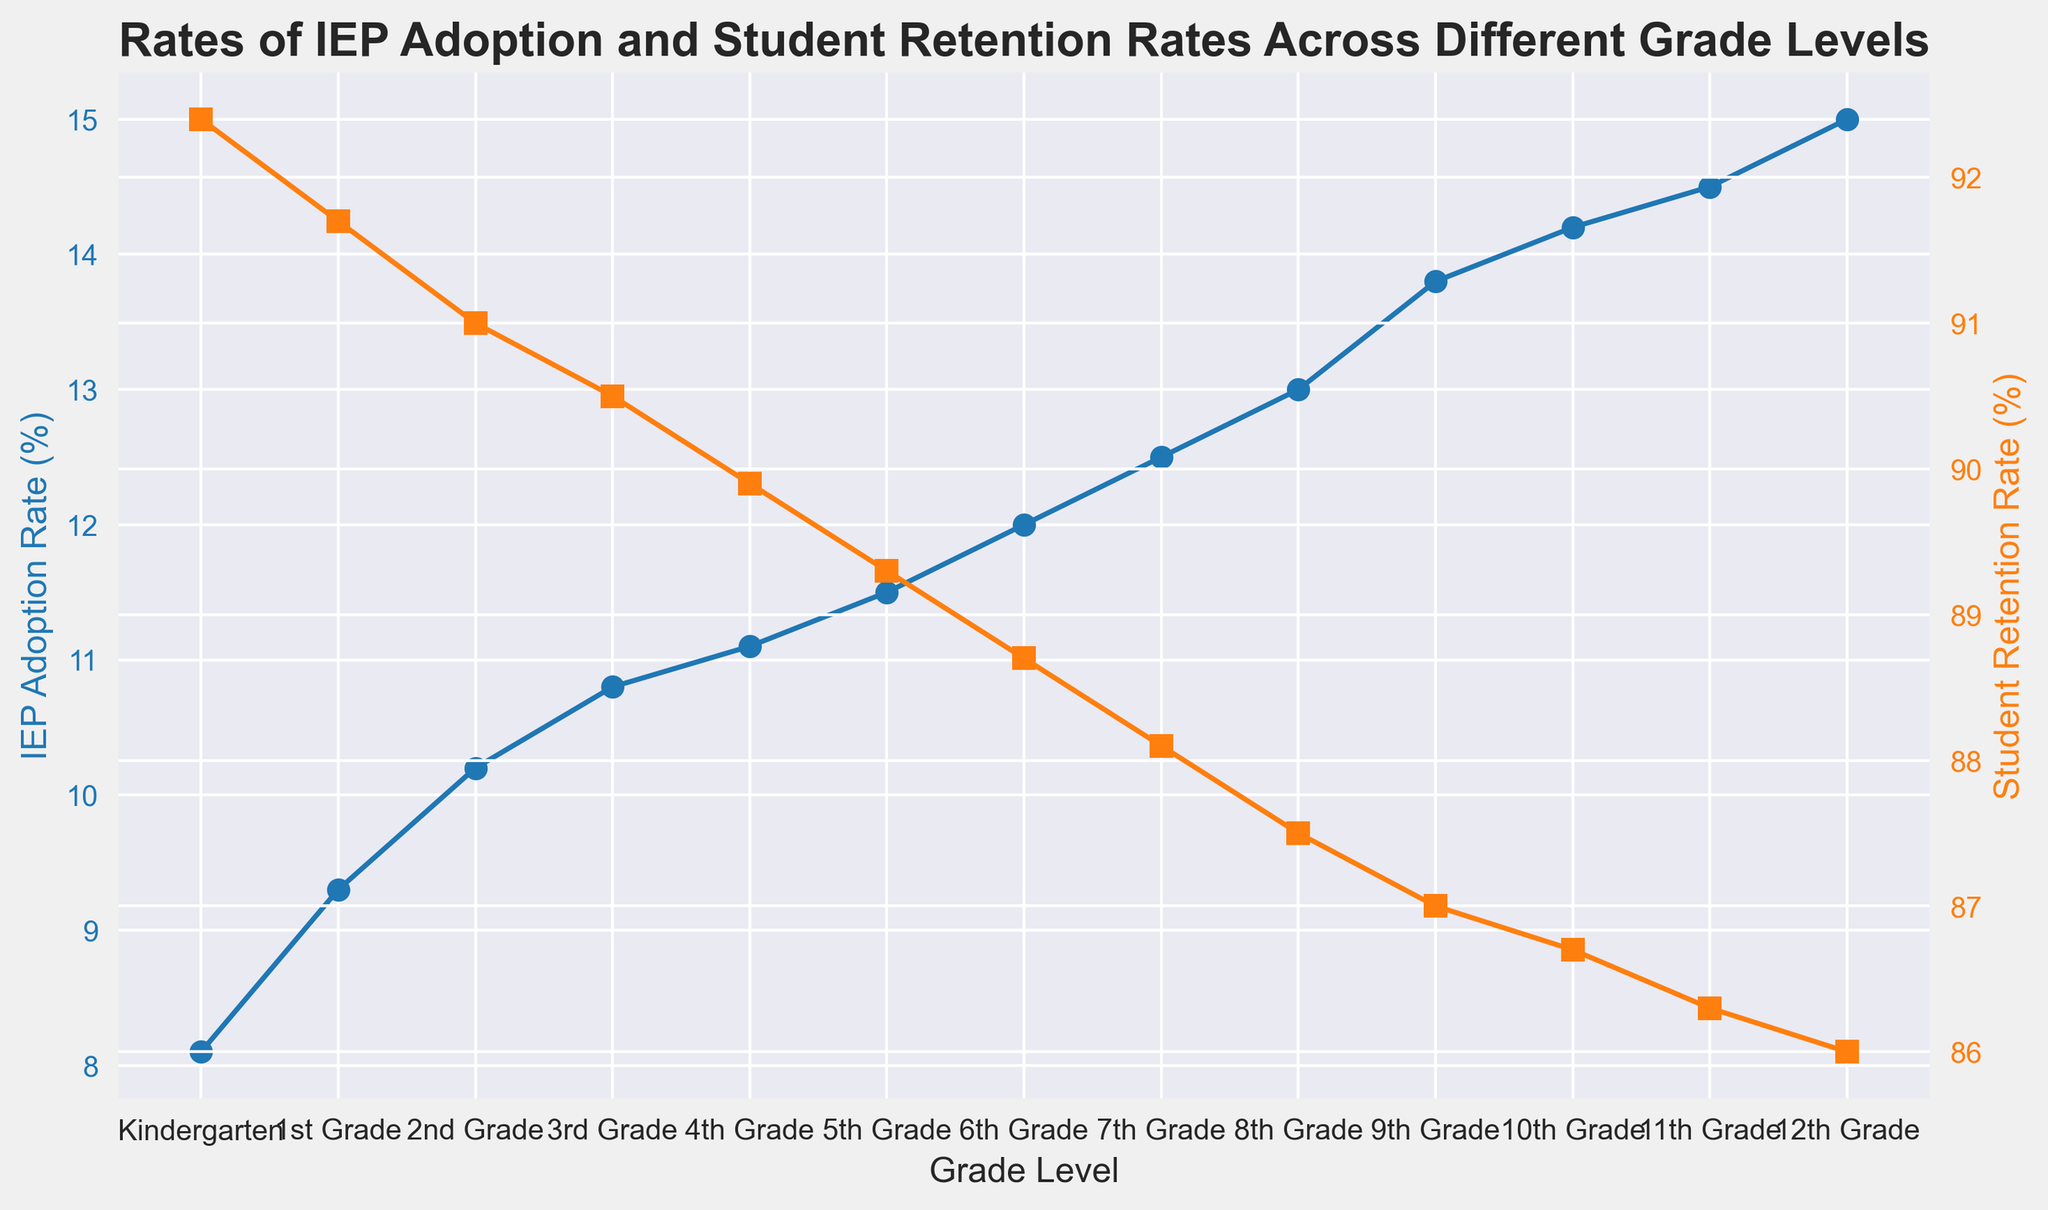What is the IEP Adoption Rate for 8th Grade? Look at the blue line marked with circles for 8th Grade. The IEP Adoption Rate reads 13.0%.
Answer: 13.0% Which grade level has the highest Student Retention Rate? Look at the orange line marked with squares and identify the highest point. The highest value is at Kindergarten with 92.4%.
Answer: Kindergarten What is the difference between the IEP Adoption Rate and Student Retention Rate for 4th Grade? The IEP Adoption Rate for 4th Grade is 11.1%, and the Student Retention Rate is 89.9%. The difference is 89.9 - 11.1 = 78.8%.
Answer: 78.8% How does the Student Retention Rate trend as the grade levels increase? Follow the orange line from Kindergarten to 12th Grade. The trend shows a gradual decrease in Student Retention Rates as grade levels increase.
Answer: Gradual decrease Is the IEP Adoption Rate above 10% in 3rd Grade? Look at the blue line for 3rd Grade. It reads 10.8%, which is above 10%.
Answer: Yes Between 9th Grade and 10th Grade, which has a higher IEP Adoption Rate? Compare the blue points for 9th and 10th Grades. 10th Grade has 14.2%, which is higher than 13.8% of 9th Grade.
Answer: 10th Grade What is the rate of change in Student Retention Rate from Kindergarten to 1st Grade? The Student Retention Rate for Kindergarten is 92.4%, and for 1st Grade is 91.7%. The rate of change is (91.7 - 92.4) = -0.7%.
Answer: -0.7% Which grade level marks the first instance where the IEP Adoption Rate is 12% or higher? Follow the blue line until it reaches or surpasses 12%. The first instance is in 6th Grade with exactly 12.0%.
Answer: 6th Grade What is the average IEP Adoption Rate from 1st Grade to 5th Grade? The IEP Adoption Rates are 9.3, 10.2, 10.8, 11.1, and 11.5. Sum them (9.3 + 10.2 + 10.8 + 11.1 + 11.5) = 52.9, then divide by the number of grades (5). The average is 52.9 / 5 = 10.58%.
Answer: 10.58% 